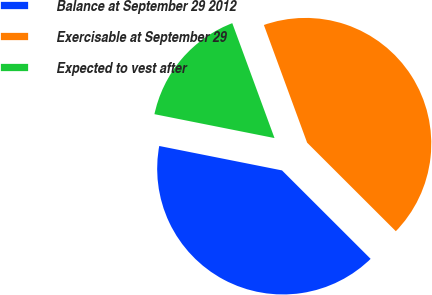Convert chart. <chart><loc_0><loc_0><loc_500><loc_500><pie_chart><fcel>Balance at September 29 2012<fcel>Exercisable at September 29<fcel>Expected to vest after<nl><fcel>40.64%<fcel>43.09%<fcel>16.27%<nl></chart> 